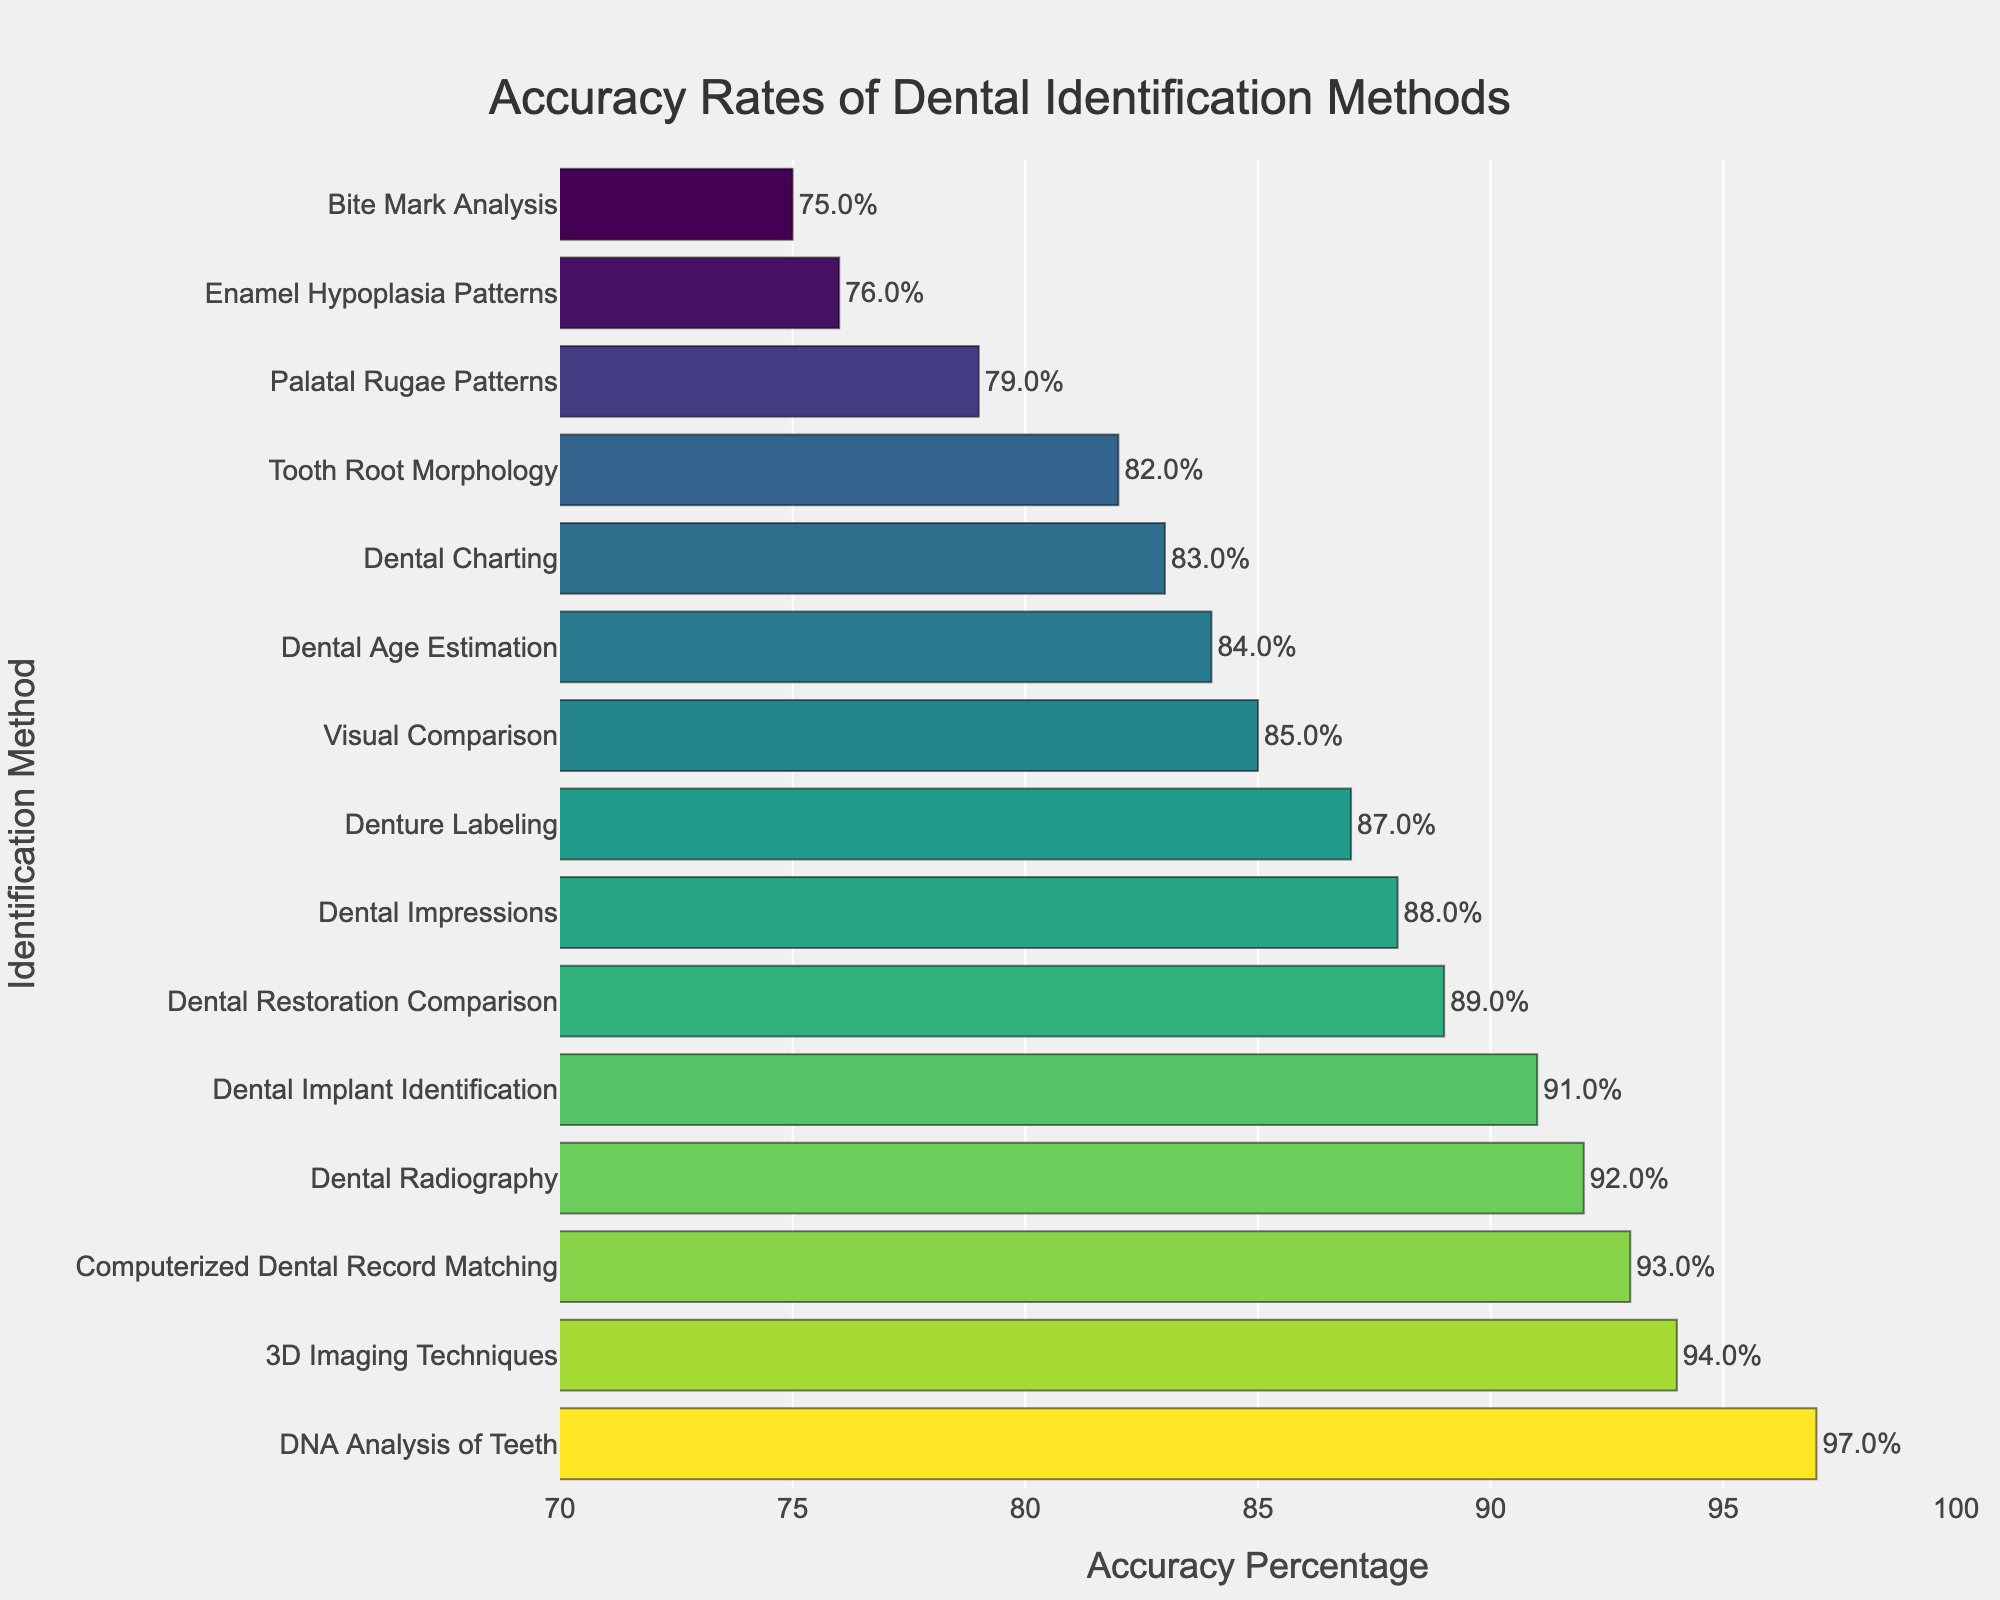Which dental identification method has the highest accuracy rate? Identify the longest bar in the chart and read the corresponding method label, which is DNA Analysis of Teeth.
Answer: DNA Analysis of Teeth Which two methods show the lowest accuracy rates, and what are their values? Find the two shortest bars in the graph, with the corresponding labels being Bite Mark Analysis and Enamel Hypoplasia Patterns. Their accuracy percentages are 75% and 76%, respectively.
Answer: Bite Mark Analysis (75%), Enamel Hypoplasia Patterns (76%) What is the difference in accuracy between Dental Radiography and Dental Impressions? Locate the bars for Dental Radiography and Dental Impressions. Dental Radiography has an accuracy of 92%, while Dental Impressions have 88%. Calculate the difference: 92% - 88% = 4%.
Answer: 4% Are more than half of the methods above 90% in accuracy? If so, how many? Count the number of methods with bars extending beyond the 90% mark. The methods above 90% in accuracy are Dental Radiography, 3D Imaging Techniques, Dental Implant Identification, Computerized Dental Record Matching, and DNA Analysis of Teeth. Therefore, 5 out of 15 methods exceed 90%, which is less than half (7.5).
Answer: No, only 5 methods are above 90% What is the average accuracy rate of the top 3 most accurate methods? First, identify the top three methods: DNA Analysis of Teeth (97%), 3D Imaging Techniques (94%), and Computerized Dental Record Matching (93%). Sum their accuracies: 97% + 94% + 93% = 284%. Then, divide by 3: 284% / 3 ≈ 94.67%.
Answer: 94.67% Which method is the second least accurate, and how much more accurate is it compared to the least accurate method? Identify the two shortest bars: Bite Mark Analysis (75%) and Enamel Hypoplasia Patterns (76%). The second least accurate method is Enamel Hypoplasia Patterns, and it is 1% more accurate than Bite Mark Analysis.
Answer: Enamel Hypoplasia Patterns (1% more accurate) Which three methods have accuracy rates closest to the median method's accuracy rate? List all accuracy percentages in ascending order: 75%, 76%, 79%, 82%, 83%, 84%, 85%, 87%, 88%, 89%, 91%, 92%, 93%, 94%, 97%. The median value is the 8th in this list, which is 87% (Denture Labeling). The three closest values around that are 85% (Visual Comparison), 88% (Dental Impressions), and 89% (Dental Restoration Comparison).
Answer: Visual Comparison (85%), Dental Impressions (88%), Dental Restoration Comparison (89%) What is the total combined accuracy of the methods with more than 90% accuracy rates? List the methods and their accuracy percentages: Dental Radiography (92%), 3D Imaging Techniques (94%), Dental Implant Identification (91%), Computerized Dental Record Matching (93%), and DNA Analysis of Teeth (97%). Add them together: 92% + 94% + 91% + 93% + 97% = 467%.
Answer: 467% Which method has an accuracy rate almost exactly in the middle of the range of values shown, and what is its accuracy? The range of values is from 75% to 97%. The midpoint is approximately (75% + 97%) / 2 = 86%. The method closest to this midpoint is Dental Impressions with an accuracy of 88%.
Answer: Dental Impressions (88%) 